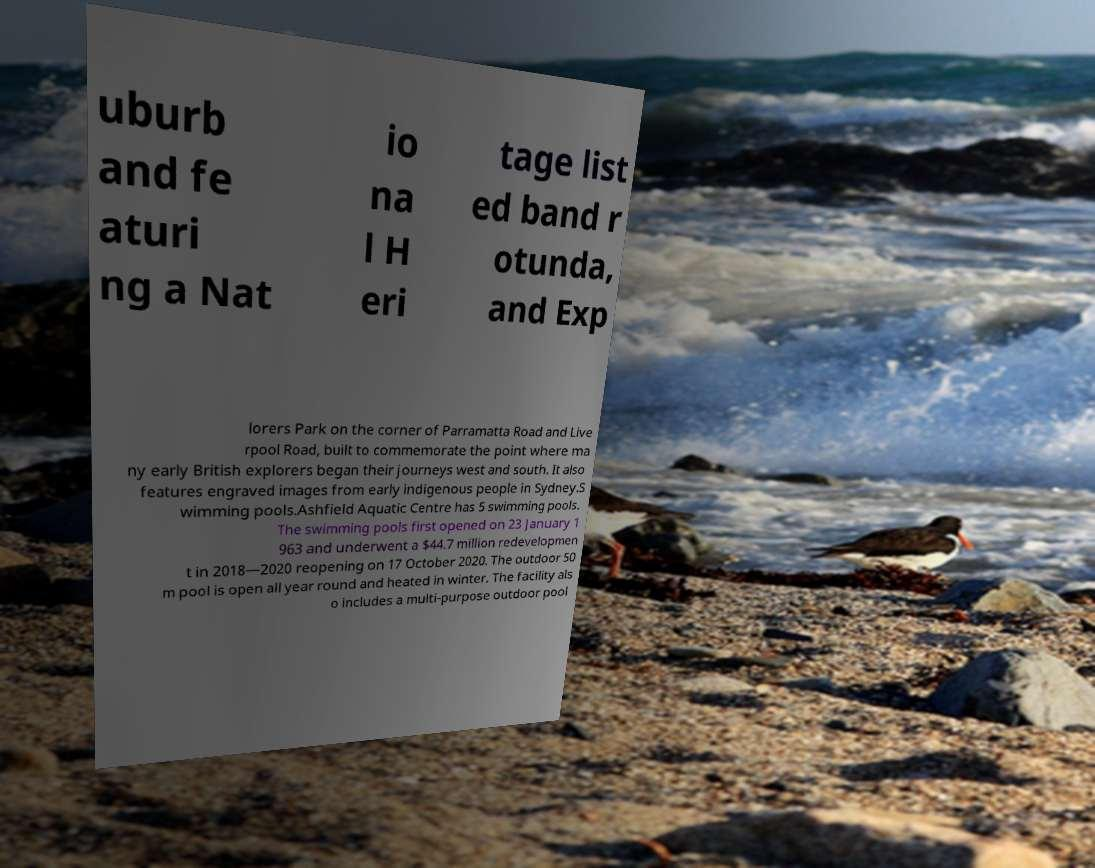I need the written content from this picture converted into text. Can you do that? uburb and fe aturi ng a Nat io na l H eri tage list ed band r otunda, and Exp lorers Park on the corner of Parramatta Road and Live rpool Road, built to commemorate the point where ma ny early British explorers began their journeys west and south. It also features engraved images from early indigenous people in Sydney.S wimming pools.Ashfield Aquatic Centre has 5 swimming pools. The swimming pools first opened on 23 January 1 963 and underwent a $44.7 million redevelopmen t in 2018—2020 reopening on 17 October 2020. The outdoor 50 m pool is open all year round and heated in winter. The facility als o includes a multi-purpose outdoor pool 